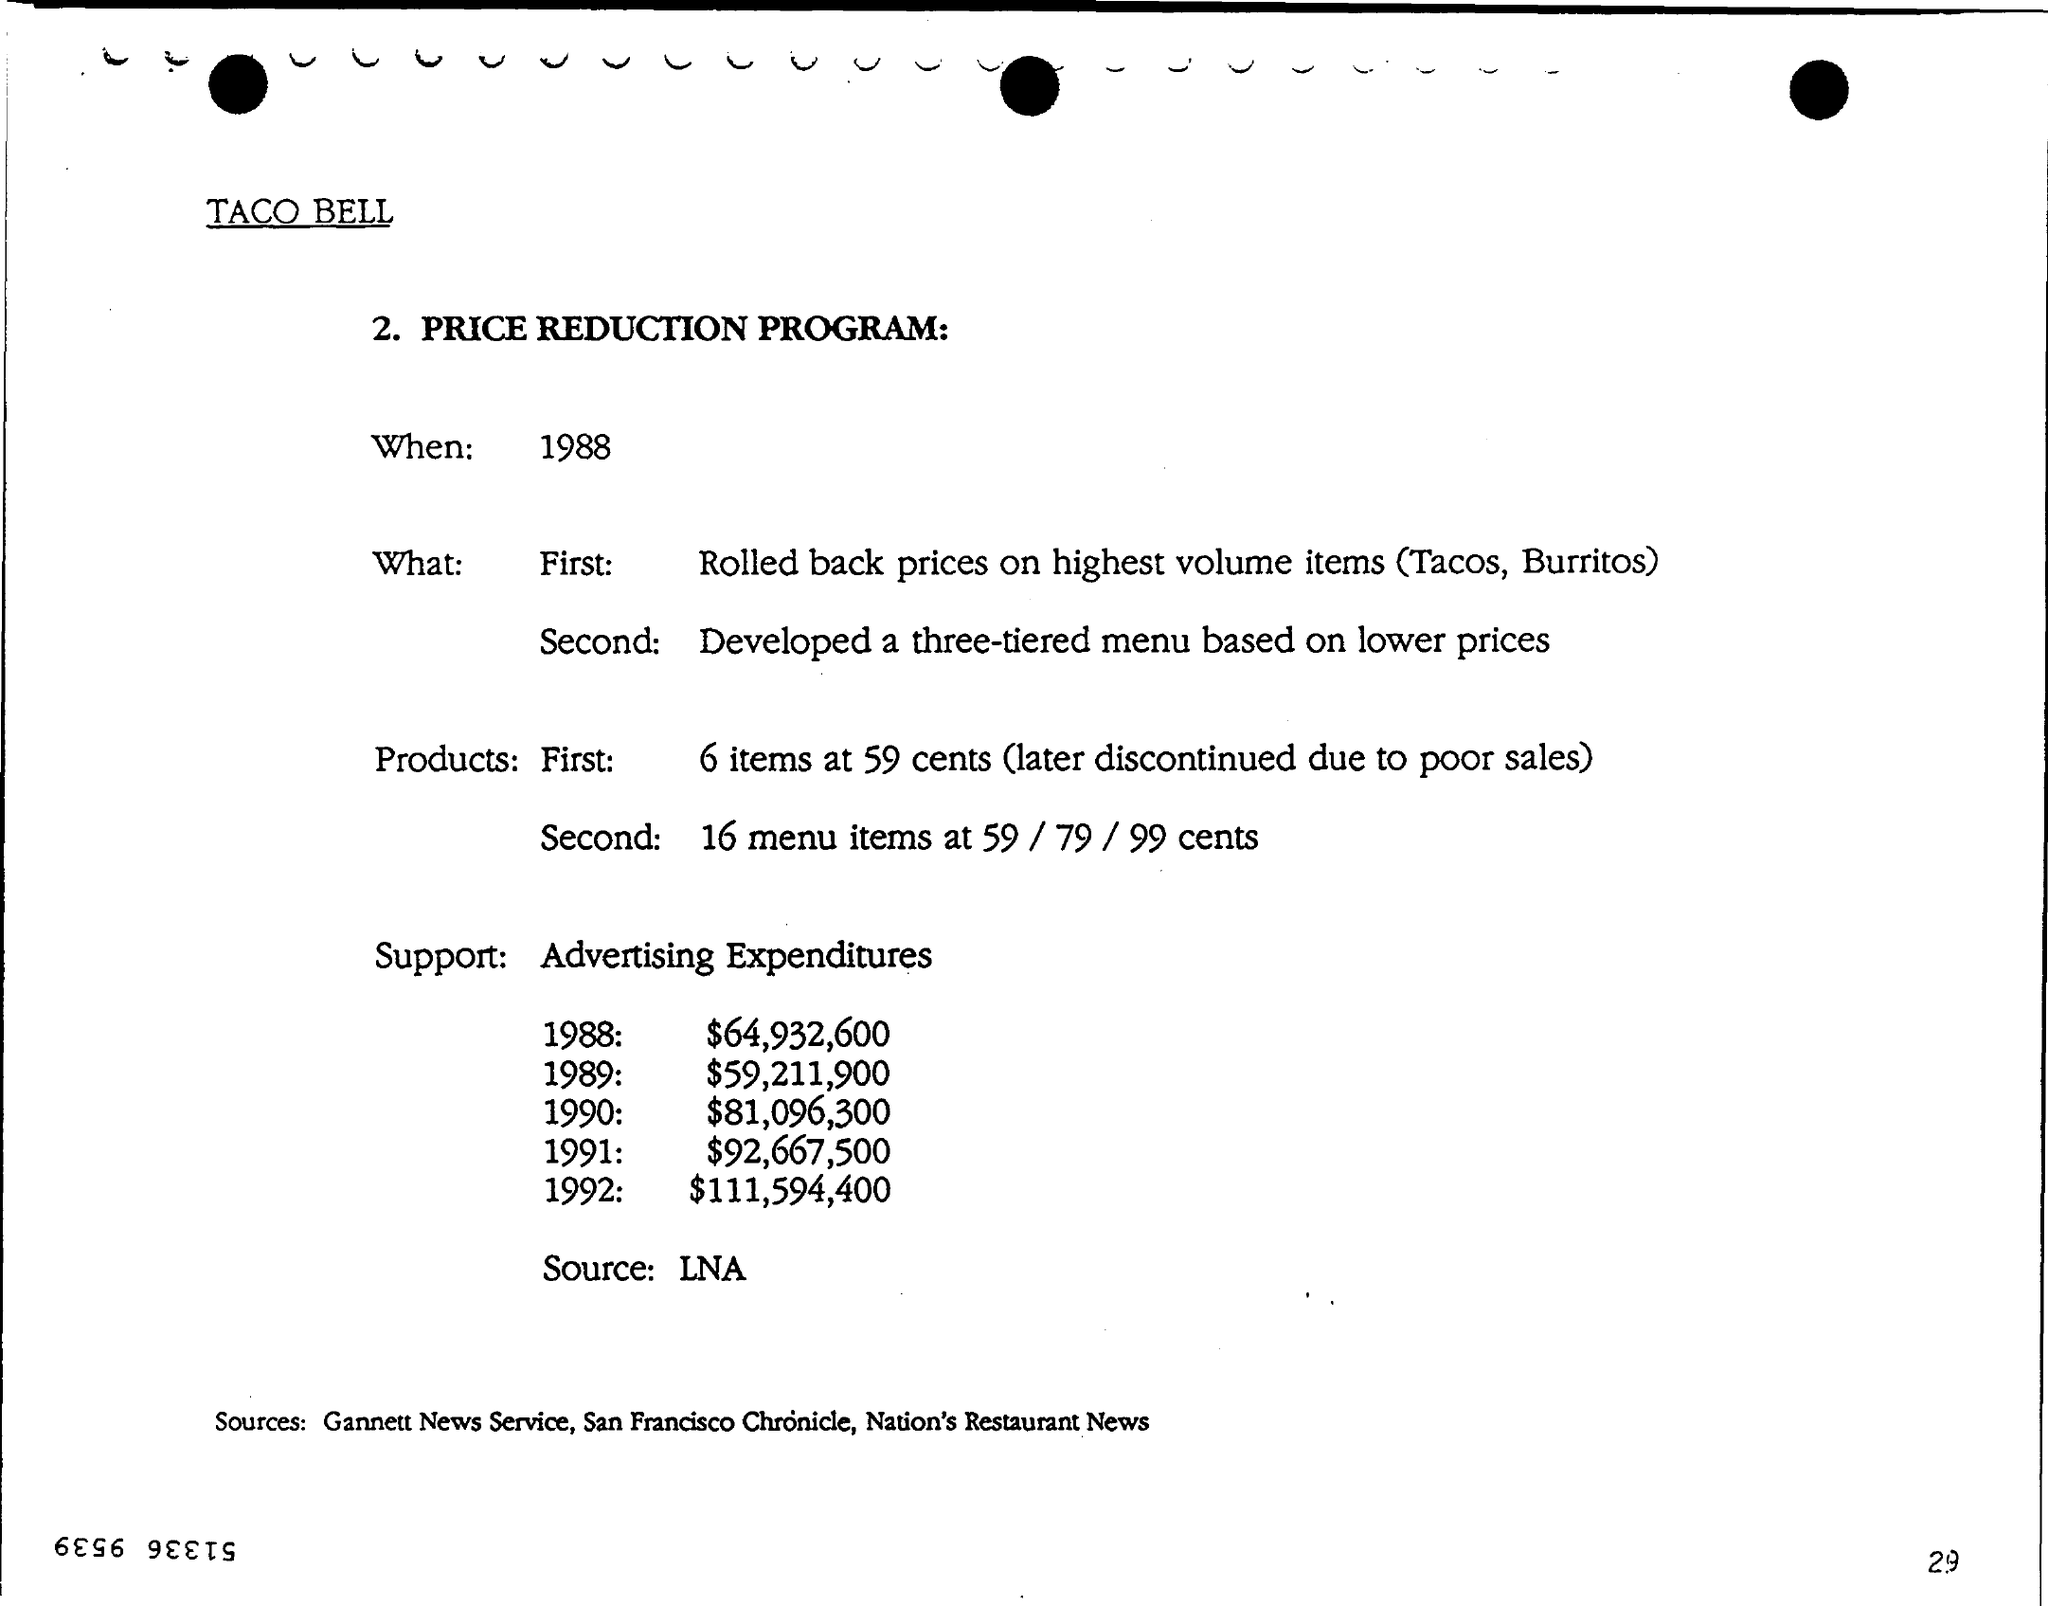Give some essential details in this illustration. In the year 1991, the amount of advertising expenditure was $92,667,500. The sources mentioned are Gannett News service, San Francisco Chronicle, and Nation's Restaurant News. This document pertains to a price reduction program. Taco Bell is mentioned. The price reduction program is set to take place in 1988. 